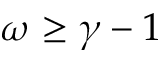<formula> <loc_0><loc_0><loc_500><loc_500>\omega \geq \gamma - 1</formula> 